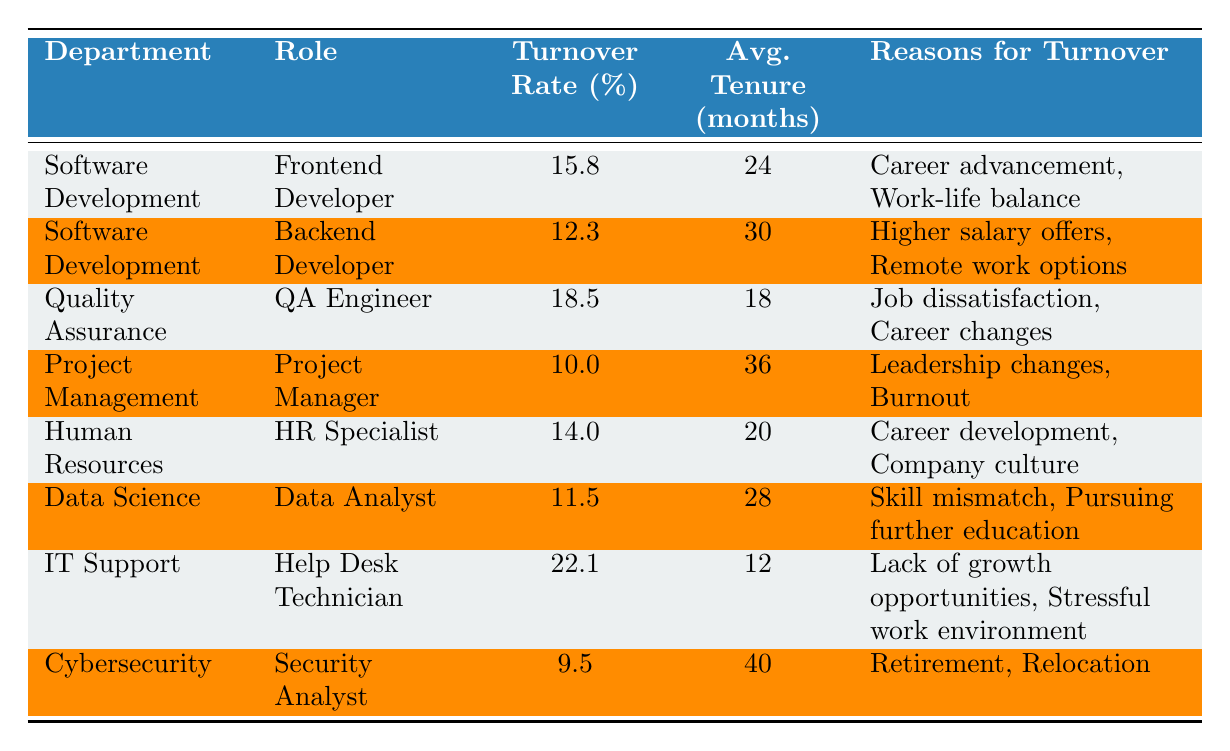What is the turnover rate for the Help Desk Technician role? The turnover rate for the Help Desk Technician role is directly listed in the table under the corresponding department and role, which shows a turnover rate of 22.1%.
Answer: 22.1% Which department has the highest turnover rate? By comparing the turnover rates listed for each department, the IT Support department has the highest turnover rate of 22.1%.
Answer: IT Support What is the average tenure of a QA Engineer? The average tenure of a QA Engineer is specified in the table as 18 months.
Answer: 18 months What is the difference in turnover rates between Cybersecurity and Project Management roles? The turnover rate for Cybersecurity (9.5%) is subtracted from the turnover rate for Project Management (10.0%), which results in a difference of 0.5%.
Answer: 0.5% Is it true that the Backend Developer has a higher average tenure than the QA Engineer? The average tenure for Backend Developer is 30 months, while for QA Engineer it is 18 months. Therefore, it is true that the Backend Developer has a higher average tenure.
Answer: Yes What is the average turnover rate for all the software development roles combined? The turnover rates for the Frontend Developer (15.8%) and Backend Developer (12.3%) are added together to get 28.1%. Then, divide that sum by 2 (the number of roles) to find the average turnover rate, which equals 14.05%.
Answer: 14.05% Which role has the lowest turnover rate? Looking at the turnover rates provided, the Security Analyst role in Cybersecurity has the lowest turnover rate of 9.5%.
Answer: Security Analyst What are the common reasons for turnover in the IT Support department? The table identifies the reasons for turnover in the IT Support department as lack of growth opportunities and a stressful work environment.
Answer: Lack of growth opportunities, stressful work environment Which role has the highest average tenure in the table? The average tenure of the Security Analyst role is noted as 40 months, which is higher than all other roles listed in the table.
Answer: Security Analyst 